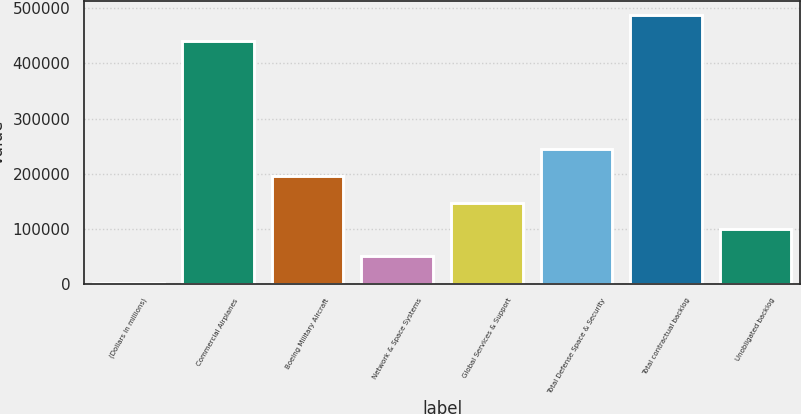Convert chart to OTSL. <chart><loc_0><loc_0><loc_500><loc_500><bar_chart><fcel>(Dollars in millions)<fcel>Commercial Airplanes<fcel>Boeing Military Aircraft<fcel>Network & Space Systems<fcel>Global Services & Support<fcel>Total Defense Space & Security<fcel>Total contractual backlog<fcel>Unobligated backlog<nl><fcel>2014<fcel>440118<fcel>196045<fcel>50521.8<fcel>147537<fcel>244553<fcel>488626<fcel>99029.6<nl></chart> 